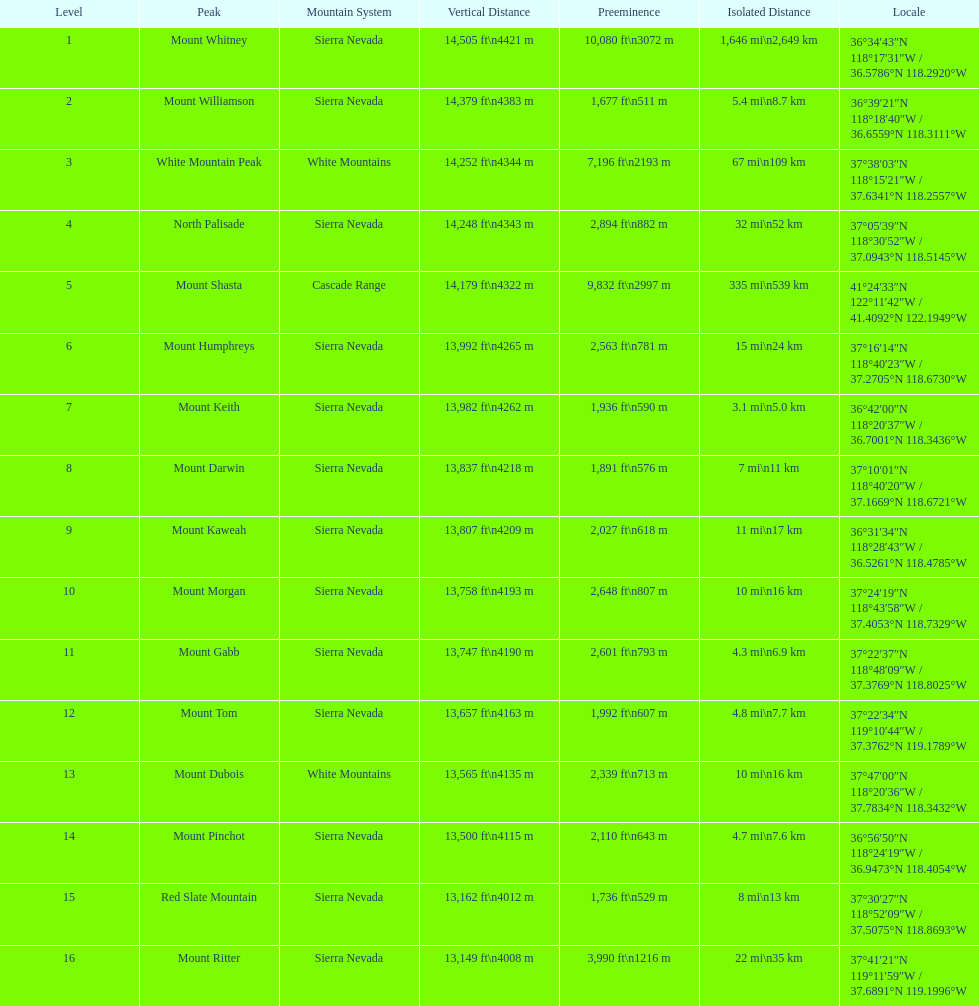What is the difference in height, in feet, between the highest and the 9th highest peak in california? 698 ft. 